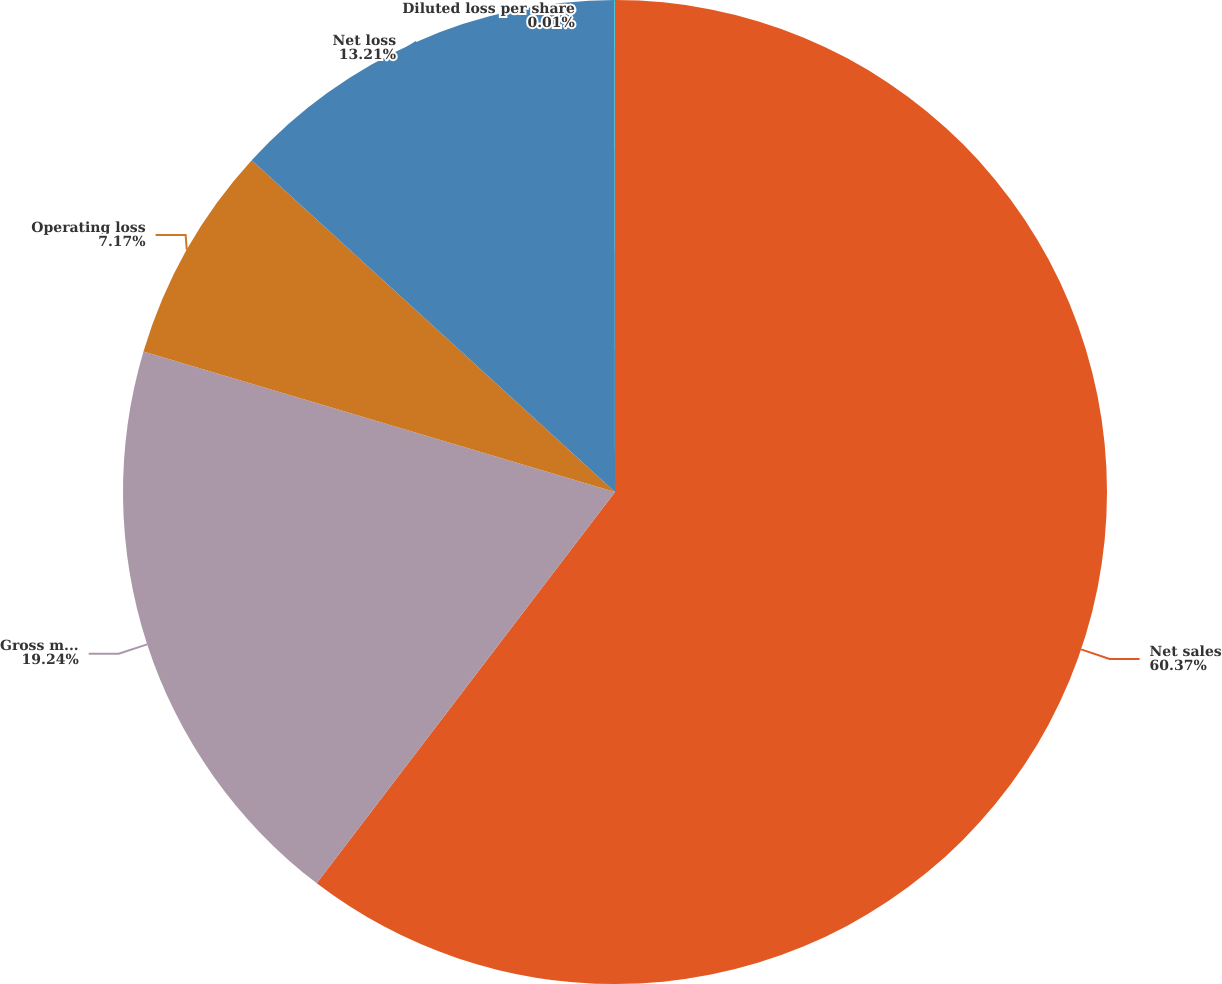Convert chart to OTSL. <chart><loc_0><loc_0><loc_500><loc_500><pie_chart><fcel>Net sales<fcel>Gross margin<fcel>Operating loss<fcel>Net loss<fcel>Diluted loss per share<nl><fcel>60.36%<fcel>19.24%<fcel>7.17%<fcel>13.21%<fcel>0.01%<nl></chart> 